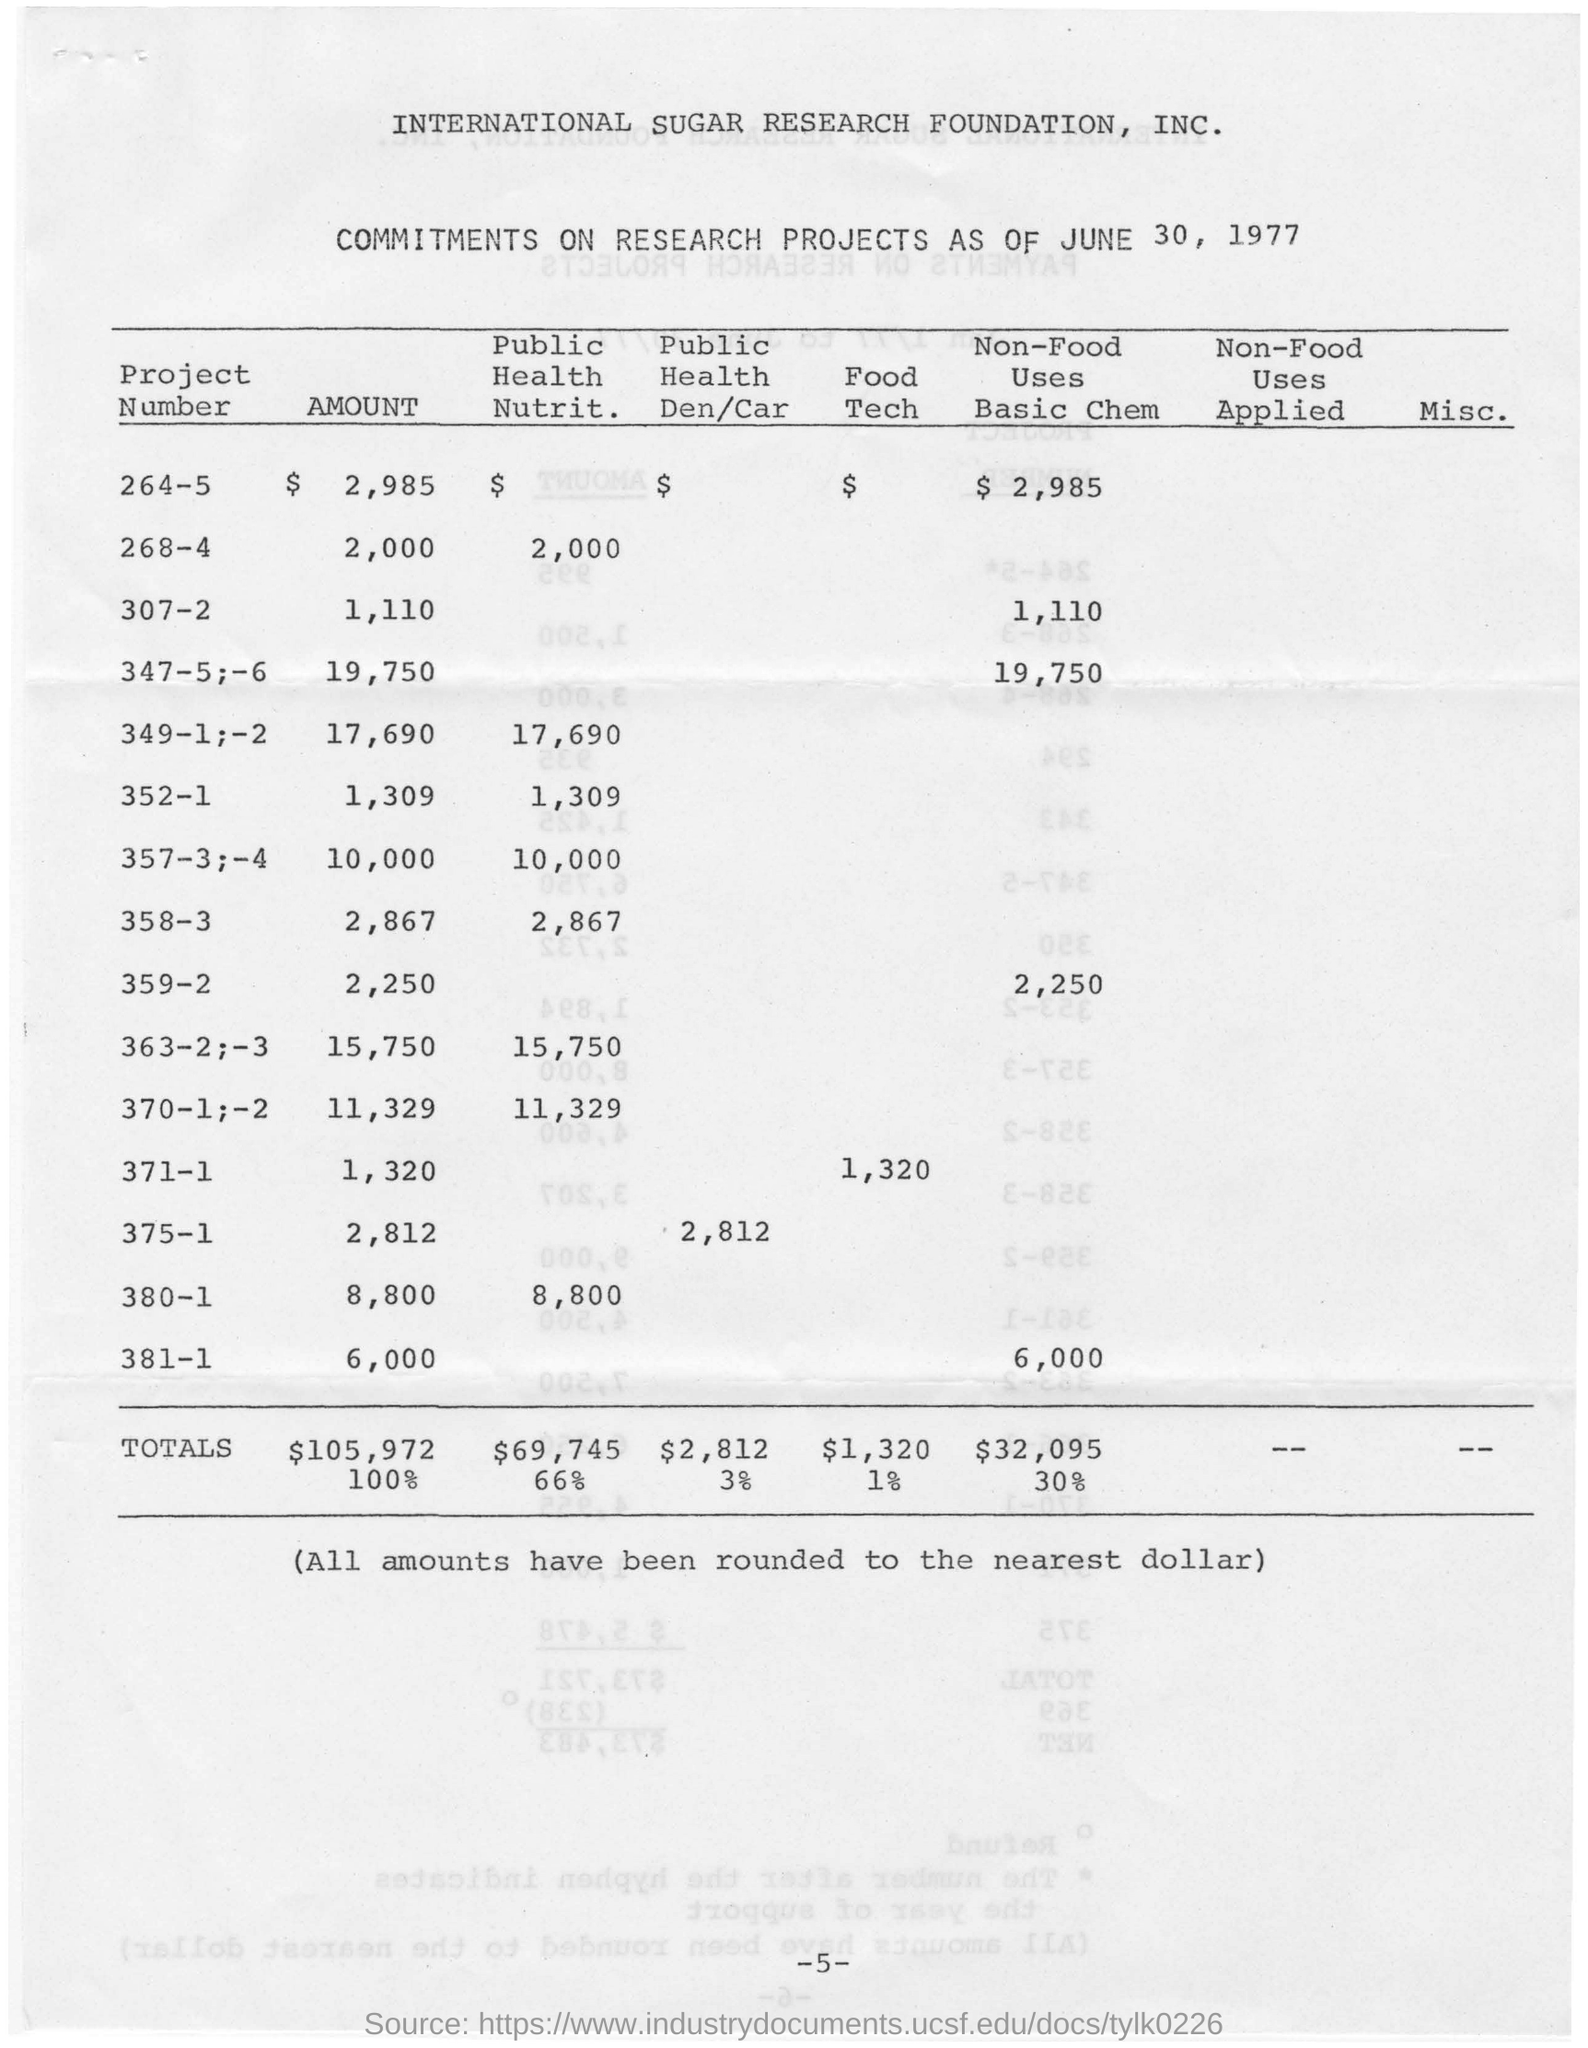List a handful of essential elements in this visual. The date mentioned at the top of the document is June 30, 1977. The total amount of Public Health Nutrition funding is $69,745. 